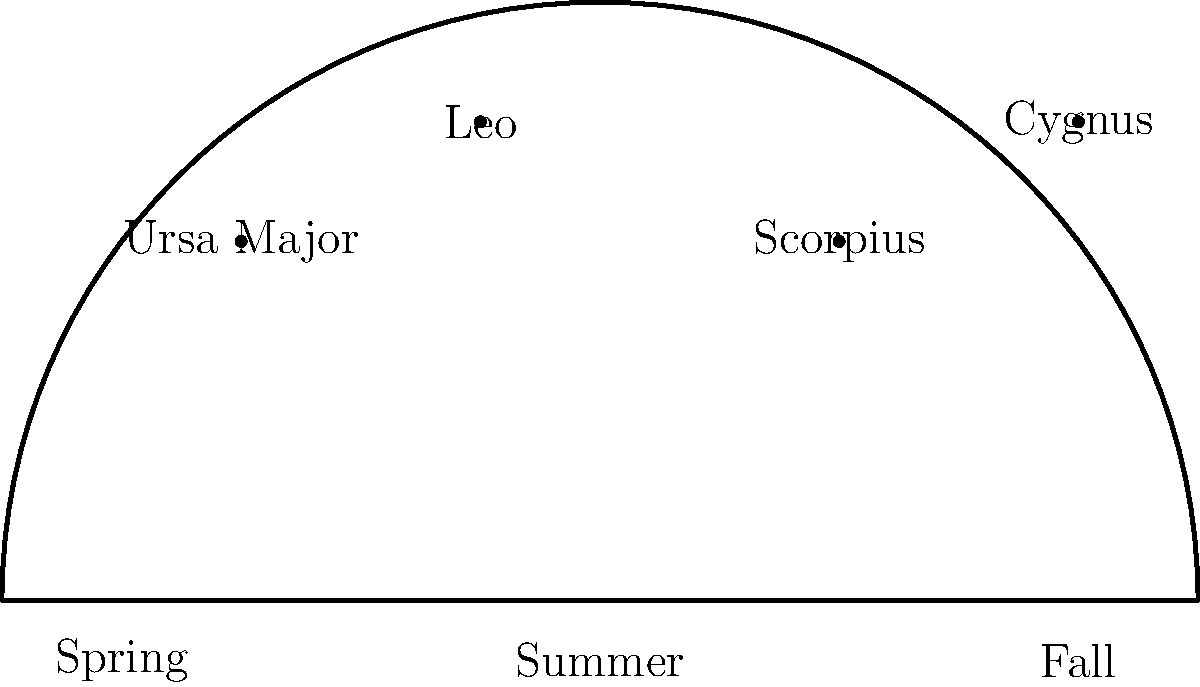Which constellation is most prominent during the summer fishing season and is often used by anglers for navigation at night? To answer this question, let's break down the information provided in the diagram and relate it to fishing seasons:

1. The diagram shows a simplified view of the night sky across different seasons.
2. We can see four constellations labeled: Ursa Major, Leo, Scorpius, and Cygnus.
3. The seasons are marked at the bottom: Spring, Summer, and Fall.
4. In astronomy, constellations visible during a particular season are typically those that appear highest in the sky during that time.
5. Looking at the diagram, we can see that Scorpius is positioned directly above the "Summer" label.
6. Scorpius is a prominent summer constellation in the Northern Hemisphere.
7. For anglers, Scorpius is particularly useful because:
   a) It's easily recognizable due to its distinctive "fishhook" shape.
   b) It's visible for much of the night during summer months.
   c) The bright star Antares in Scorpius can be used as a reference point for navigation.

Therefore, based on its prominence during the summer fishing season and its usefulness for nighttime navigation, Scorpius is the constellation that best fits the criteria in the question.
Answer: Scorpius 